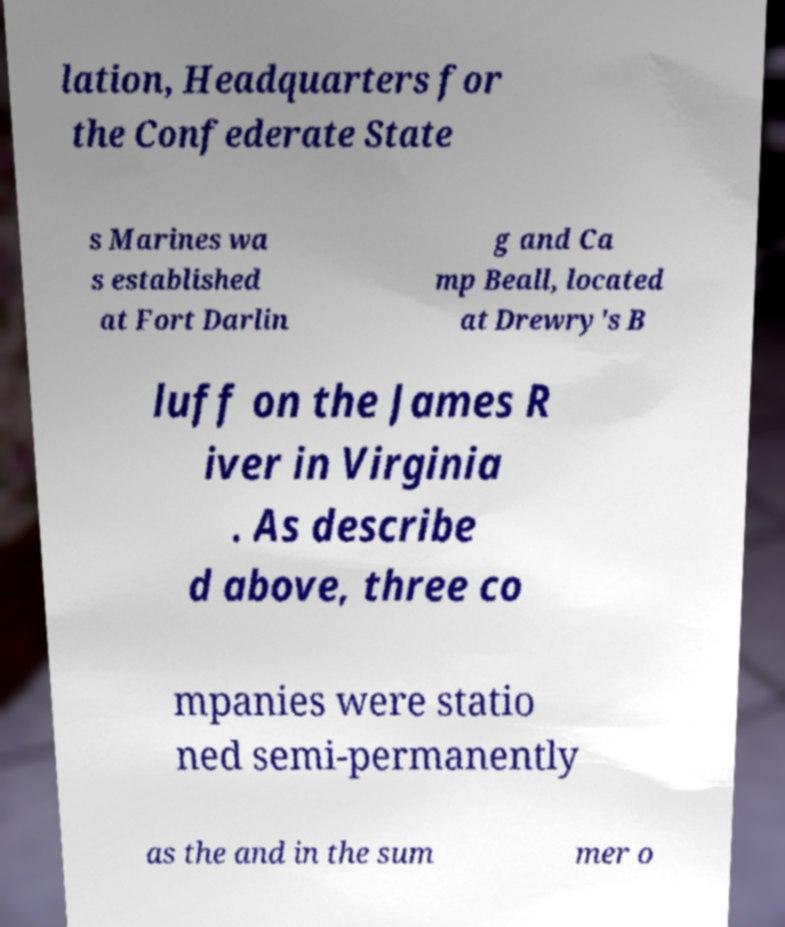For documentation purposes, I need the text within this image transcribed. Could you provide that? lation, Headquarters for the Confederate State s Marines wa s established at Fort Darlin g and Ca mp Beall, located at Drewry's B luff on the James R iver in Virginia . As describe d above, three co mpanies were statio ned semi-permanently as the and in the sum mer o 